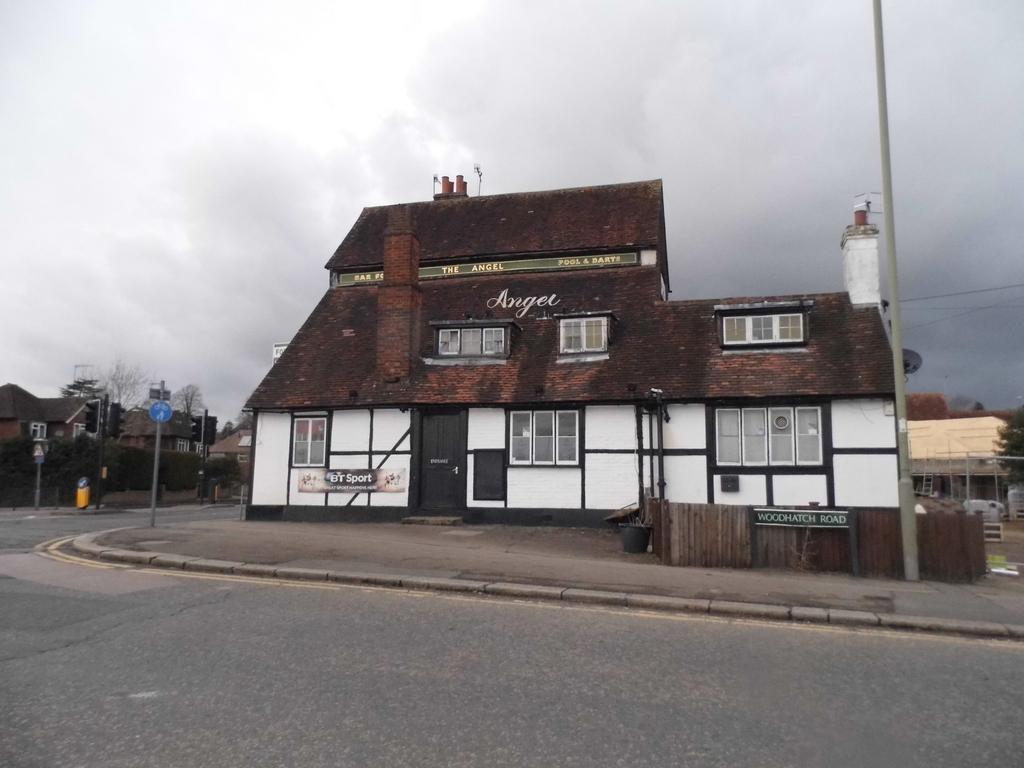Can you describe this image briefly? This is the picture of a city. In this picture there are buildings and trees and there are poles on the footpath and there are boards on the pole. At the top there are clouds. At the bottom there is a road. 